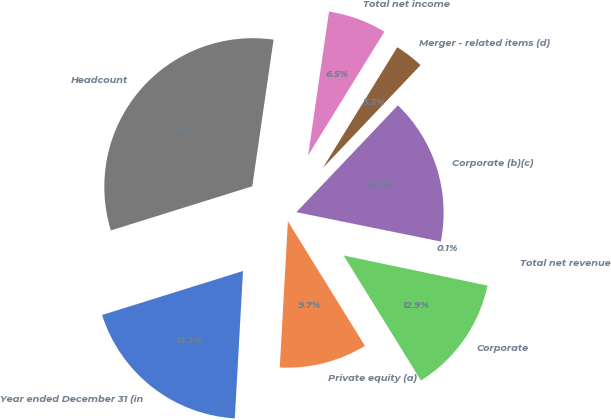Convert chart. <chart><loc_0><loc_0><loc_500><loc_500><pie_chart><fcel>Year ended December 31 (in<fcel>Private equity (a)<fcel>Corporate<fcel>Total net revenue<fcel>Corporate (b)(c)<fcel>Merger - related items (d)<fcel>Total net income<fcel>Headcount<nl><fcel>19.3%<fcel>9.7%<fcel>12.9%<fcel>0.09%<fcel>16.1%<fcel>3.3%<fcel>6.5%<fcel>32.11%<nl></chart> 